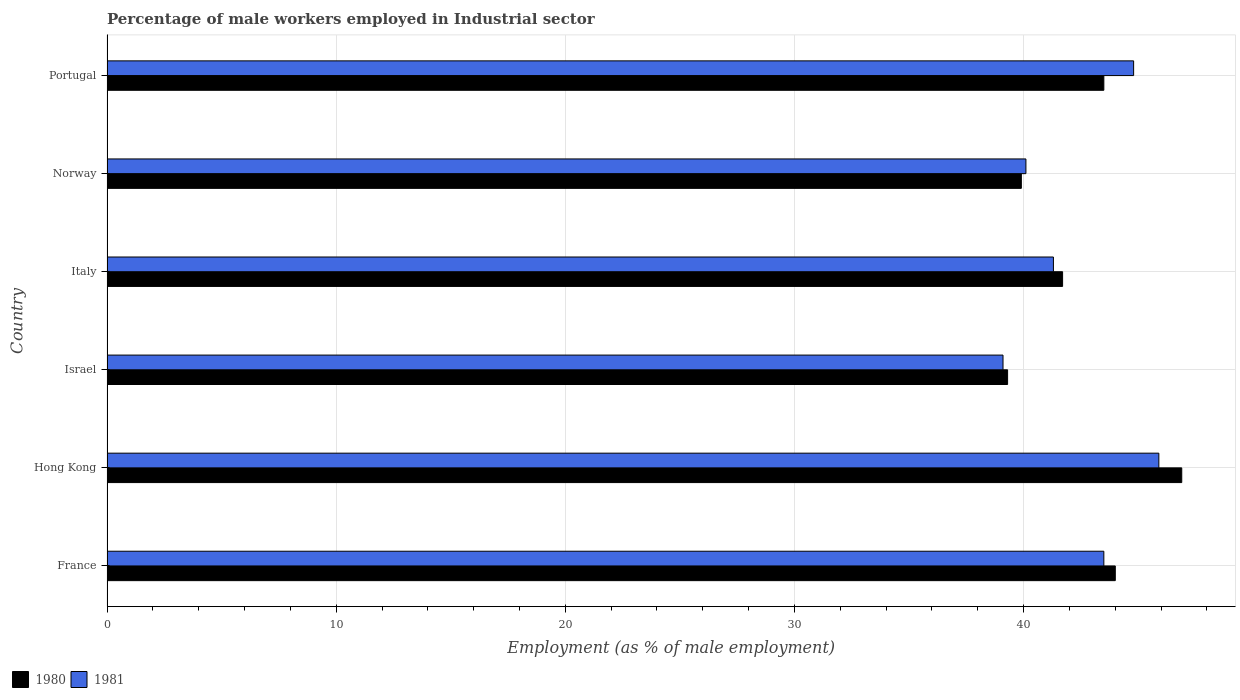Are the number of bars per tick equal to the number of legend labels?
Your answer should be very brief. Yes. Are the number of bars on each tick of the Y-axis equal?
Provide a succinct answer. Yes. How many bars are there on the 4th tick from the bottom?
Keep it short and to the point. 2. What is the label of the 5th group of bars from the top?
Make the answer very short. Hong Kong. In how many cases, is the number of bars for a given country not equal to the number of legend labels?
Ensure brevity in your answer.  0. What is the percentage of male workers employed in Industrial sector in 1981 in France?
Ensure brevity in your answer.  43.5. Across all countries, what is the maximum percentage of male workers employed in Industrial sector in 1981?
Your answer should be very brief. 45.9. Across all countries, what is the minimum percentage of male workers employed in Industrial sector in 1981?
Keep it short and to the point. 39.1. In which country was the percentage of male workers employed in Industrial sector in 1980 maximum?
Provide a short and direct response. Hong Kong. What is the total percentage of male workers employed in Industrial sector in 1981 in the graph?
Ensure brevity in your answer.  254.7. What is the difference between the percentage of male workers employed in Industrial sector in 1981 in Hong Kong and that in Portugal?
Your answer should be very brief. 1.1. What is the difference between the percentage of male workers employed in Industrial sector in 1980 in Hong Kong and the percentage of male workers employed in Industrial sector in 1981 in Norway?
Make the answer very short. 6.8. What is the average percentage of male workers employed in Industrial sector in 1981 per country?
Give a very brief answer. 42.45. What is the difference between the percentage of male workers employed in Industrial sector in 1981 and percentage of male workers employed in Industrial sector in 1980 in Portugal?
Keep it short and to the point. 1.3. In how many countries, is the percentage of male workers employed in Industrial sector in 1981 greater than 38 %?
Your answer should be very brief. 6. What is the ratio of the percentage of male workers employed in Industrial sector in 1981 in Hong Kong to that in Israel?
Give a very brief answer. 1.17. Is the percentage of male workers employed in Industrial sector in 1980 in Israel less than that in Italy?
Provide a succinct answer. Yes. What is the difference between the highest and the second highest percentage of male workers employed in Industrial sector in 1980?
Offer a very short reply. 2.9. What is the difference between the highest and the lowest percentage of male workers employed in Industrial sector in 1981?
Keep it short and to the point. 6.8. In how many countries, is the percentage of male workers employed in Industrial sector in 1980 greater than the average percentage of male workers employed in Industrial sector in 1980 taken over all countries?
Offer a very short reply. 3. Is the sum of the percentage of male workers employed in Industrial sector in 1981 in Hong Kong and Portugal greater than the maximum percentage of male workers employed in Industrial sector in 1980 across all countries?
Ensure brevity in your answer.  Yes. What does the 1st bar from the top in Hong Kong represents?
Provide a succinct answer. 1981. What does the 1st bar from the bottom in Italy represents?
Keep it short and to the point. 1980. How many bars are there?
Provide a succinct answer. 12. Are all the bars in the graph horizontal?
Keep it short and to the point. Yes. How many countries are there in the graph?
Provide a short and direct response. 6. What is the difference between two consecutive major ticks on the X-axis?
Your response must be concise. 10. Are the values on the major ticks of X-axis written in scientific E-notation?
Keep it short and to the point. No. Does the graph contain any zero values?
Make the answer very short. No. How are the legend labels stacked?
Keep it short and to the point. Horizontal. What is the title of the graph?
Keep it short and to the point. Percentage of male workers employed in Industrial sector. Does "1974" appear as one of the legend labels in the graph?
Provide a short and direct response. No. What is the label or title of the X-axis?
Your answer should be compact. Employment (as % of male employment). What is the label or title of the Y-axis?
Provide a succinct answer. Country. What is the Employment (as % of male employment) of 1981 in France?
Give a very brief answer. 43.5. What is the Employment (as % of male employment) in 1980 in Hong Kong?
Your answer should be very brief. 46.9. What is the Employment (as % of male employment) in 1981 in Hong Kong?
Ensure brevity in your answer.  45.9. What is the Employment (as % of male employment) in 1980 in Israel?
Your answer should be compact. 39.3. What is the Employment (as % of male employment) in 1981 in Israel?
Make the answer very short. 39.1. What is the Employment (as % of male employment) in 1980 in Italy?
Offer a very short reply. 41.7. What is the Employment (as % of male employment) in 1981 in Italy?
Ensure brevity in your answer.  41.3. What is the Employment (as % of male employment) of 1980 in Norway?
Give a very brief answer. 39.9. What is the Employment (as % of male employment) in 1981 in Norway?
Ensure brevity in your answer.  40.1. What is the Employment (as % of male employment) in 1980 in Portugal?
Your answer should be very brief. 43.5. What is the Employment (as % of male employment) of 1981 in Portugal?
Make the answer very short. 44.8. Across all countries, what is the maximum Employment (as % of male employment) in 1980?
Ensure brevity in your answer.  46.9. Across all countries, what is the maximum Employment (as % of male employment) in 1981?
Offer a very short reply. 45.9. Across all countries, what is the minimum Employment (as % of male employment) of 1980?
Keep it short and to the point. 39.3. Across all countries, what is the minimum Employment (as % of male employment) in 1981?
Provide a short and direct response. 39.1. What is the total Employment (as % of male employment) of 1980 in the graph?
Your answer should be compact. 255.3. What is the total Employment (as % of male employment) of 1981 in the graph?
Provide a succinct answer. 254.7. What is the difference between the Employment (as % of male employment) in 1980 in France and that in Italy?
Give a very brief answer. 2.3. What is the difference between the Employment (as % of male employment) in 1981 in France and that in Norway?
Make the answer very short. 3.4. What is the difference between the Employment (as % of male employment) of 1980 in France and that in Portugal?
Offer a very short reply. 0.5. What is the difference between the Employment (as % of male employment) in 1981 in France and that in Portugal?
Offer a very short reply. -1.3. What is the difference between the Employment (as % of male employment) of 1980 in Hong Kong and that in Israel?
Offer a terse response. 7.6. What is the difference between the Employment (as % of male employment) of 1981 in Hong Kong and that in Italy?
Your answer should be compact. 4.6. What is the difference between the Employment (as % of male employment) of 1980 in Hong Kong and that in Norway?
Your answer should be very brief. 7. What is the difference between the Employment (as % of male employment) of 1981 in Hong Kong and that in Norway?
Your answer should be compact. 5.8. What is the difference between the Employment (as % of male employment) in 1980 in Hong Kong and that in Portugal?
Give a very brief answer. 3.4. What is the difference between the Employment (as % of male employment) in 1980 in Israel and that in Italy?
Give a very brief answer. -2.4. What is the difference between the Employment (as % of male employment) of 1981 in Israel and that in Italy?
Your answer should be compact. -2.2. What is the difference between the Employment (as % of male employment) of 1981 in Israel and that in Norway?
Your answer should be compact. -1. What is the difference between the Employment (as % of male employment) of 1981 in Israel and that in Portugal?
Provide a succinct answer. -5.7. What is the difference between the Employment (as % of male employment) of 1980 in Italy and that in Norway?
Your response must be concise. 1.8. What is the difference between the Employment (as % of male employment) of 1981 in Italy and that in Portugal?
Your answer should be compact. -3.5. What is the difference between the Employment (as % of male employment) in 1981 in Norway and that in Portugal?
Keep it short and to the point. -4.7. What is the difference between the Employment (as % of male employment) of 1980 in France and the Employment (as % of male employment) of 1981 in Italy?
Provide a succinct answer. 2.7. What is the difference between the Employment (as % of male employment) in 1980 in France and the Employment (as % of male employment) in 1981 in Norway?
Your answer should be compact. 3.9. What is the difference between the Employment (as % of male employment) in 1980 in Hong Kong and the Employment (as % of male employment) in 1981 in Israel?
Your answer should be compact. 7.8. What is the difference between the Employment (as % of male employment) of 1980 in Hong Kong and the Employment (as % of male employment) of 1981 in Italy?
Provide a short and direct response. 5.6. What is the difference between the Employment (as % of male employment) of 1980 in Hong Kong and the Employment (as % of male employment) of 1981 in Norway?
Offer a very short reply. 6.8. What is the difference between the Employment (as % of male employment) in 1980 in Hong Kong and the Employment (as % of male employment) in 1981 in Portugal?
Give a very brief answer. 2.1. What is the difference between the Employment (as % of male employment) of 1980 in Israel and the Employment (as % of male employment) of 1981 in Italy?
Offer a terse response. -2. What is the difference between the Employment (as % of male employment) of 1980 in Israel and the Employment (as % of male employment) of 1981 in Portugal?
Provide a short and direct response. -5.5. What is the difference between the Employment (as % of male employment) of 1980 in Italy and the Employment (as % of male employment) of 1981 in Norway?
Offer a very short reply. 1.6. What is the average Employment (as % of male employment) of 1980 per country?
Ensure brevity in your answer.  42.55. What is the average Employment (as % of male employment) in 1981 per country?
Your answer should be very brief. 42.45. What is the difference between the Employment (as % of male employment) of 1980 and Employment (as % of male employment) of 1981 in Hong Kong?
Make the answer very short. 1. What is the difference between the Employment (as % of male employment) of 1980 and Employment (as % of male employment) of 1981 in Israel?
Offer a very short reply. 0.2. What is the difference between the Employment (as % of male employment) of 1980 and Employment (as % of male employment) of 1981 in Italy?
Your answer should be very brief. 0.4. What is the difference between the Employment (as % of male employment) in 1980 and Employment (as % of male employment) in 1981 in Norway?
Provide a short and direct response. -0.2. What is the difference between the Employment (as % of male employment) of 1980 and Employment (as % of male employment) of 1981 in Portugal?
Your response must be concise. -1.3. What is the ratio of the Employment (as % of male employment) in 1980 in France to that in Hong Kong?
Your response must be concise. 0.94. What is the ratio of the Employment (as % of male employment) of 1981 in France to that in Hong Kong?
Offer a very short reply. 0.95. What is the ratio of the Employment (as % of male employment) in 1980 in France to that in Israel?
Offer a terse response. 1.12. What is the ratio of the Employment (as % of male employment) of 1981 in France to that in Israel?
Your response must be concise. 1.11. What is the ratio of the Employment (as % of male employment) in 1980 in France to that in Italy?
Your answer should be very brief. 1.06. What is the ratio of the Employment (as % of male employment) in 1981 in France to that in Italy?
Provide a short and direct response. 1.05. What is the ratio of the Employment (as % of male employment) in 1980 in France to that in Norway?
Ensure brevity in your answer.  1.1. What is the ratio of the Employment (as % of male employment) of 1981 in France to that in Norway?
Provide a succinct answer. 1.08. What is the ratio of the Employment (as % of male employment) in 1980 in France to that in Portugal?
Give a very brief answer. 1.01. What is the ratio of the Employment (as % of male employment) in 1981 in France to that in Portugal?
Give a very brief answer. 0.97. What is the ratio of the Employment (as % of male employment) in 1980 in Hong Kong to that in Israel?
Your answer should be compact. 1.19. What is the ratio of the Employment (as % of male employment) in 1981 in Hong Kong to that in Israel?
Give a very brief answer. 1.17. What is the ratio of the Employment (as % of male employment) in 1980 in Hong Kong to that in Italy?
Keep it short and to the point. 1.12. What is the ratio of the Employment (as % of male employment) in 1981 in Hong Kong to that in Italy?
Give a very brief answer. 1.11. What is the ratio of the Employment (as % of male employment) of 1980 in Hong Kong to that in Norway?
Keep it short and to the point. 1.18. What is the ratio of the Employment (as % of male employment) of 1981 in Hong Kong to that in Norway?
Your answer should be compact. 1.14. What is the ratio of the Employment (as % of male employment) in 1980 in Hong Kong to that in Portugal?
Your answer should be compact. 1.08. What is the ratio of the Employment (as % of male employment) in 1981 in Hong Kong to that in Portugal?
Provide a succinct answer. 1.02. What is the ratio of the Employment (as % of male employment) in 1980 in Israel to that in Italy?
Your response must be concise. 0.94. What is the ratio of the Employment (as % of male employment) in 1981 in Israel to that in Italy?
Your response must be concise. 0.95. What is the ratio of the Employment (as % of male employment) in 1980 in Israel to that in Norway?
Provide a succinct answer. 0.98. What is the ratio of the Employment (as % of male employment) in 1981 in Israel to that in Norway?
Keep it short and to the point. 0.98. What is the ratio of the Employment (as % of male employment) in 1980 in Israel to that in Portugal?
Provide a succinct answer. 0.9. What is the ratio of the Employment (as % of male employment) in 1981 in Israel to that in Portugal?
Make the answer very short. 0.87. What is the ratio of the Employment (as % of male employment) in 1980 in Italy to that in Norway?
Keep it short and to the point. 1.05. What is the ratio of the Employment (as % of male employment) of 1981 in Italy to that in Norway?
Keep it short and to the point. 1.03. What is the ratio of the Employment (as % of male employment) of 1980 in Italy to that in Portugal?
Ensure brevity in your answer.  0.96. What is the ratio of the Employment (as % of male employment) of 1981 in Italy to that in Portugal?
Offer a terse response. 0.92. What is the ratio of the Employment (as % of male employment) in 1980 in Norway to that in Portugal?
Give a very brief answer. 0.92. What is the ratio of the Employment (as % of male employment) in 1981 in Norway to that in Portugal?
Provide a succinct answer. 0.9. What is the difference between the highest and the lowest Employment (as % of male employment) in 1980?
Offer a very short reply. 7.6. What is the difference between the highest and the lowest Employment (as % of male employment) in 1981?
Give a very brief answer. 6.8. 